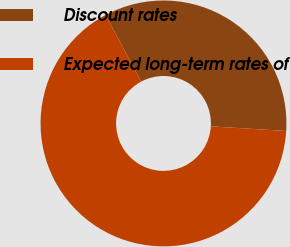Convert chart to OTSL. <chart><loc_0><loc_0><loc_500><loc_500><pie_chart><fcel>Discount rates<fcel>Expected long-term rates of<nl><fcel>33.78%<fcel>66.22%<nl></chart> 